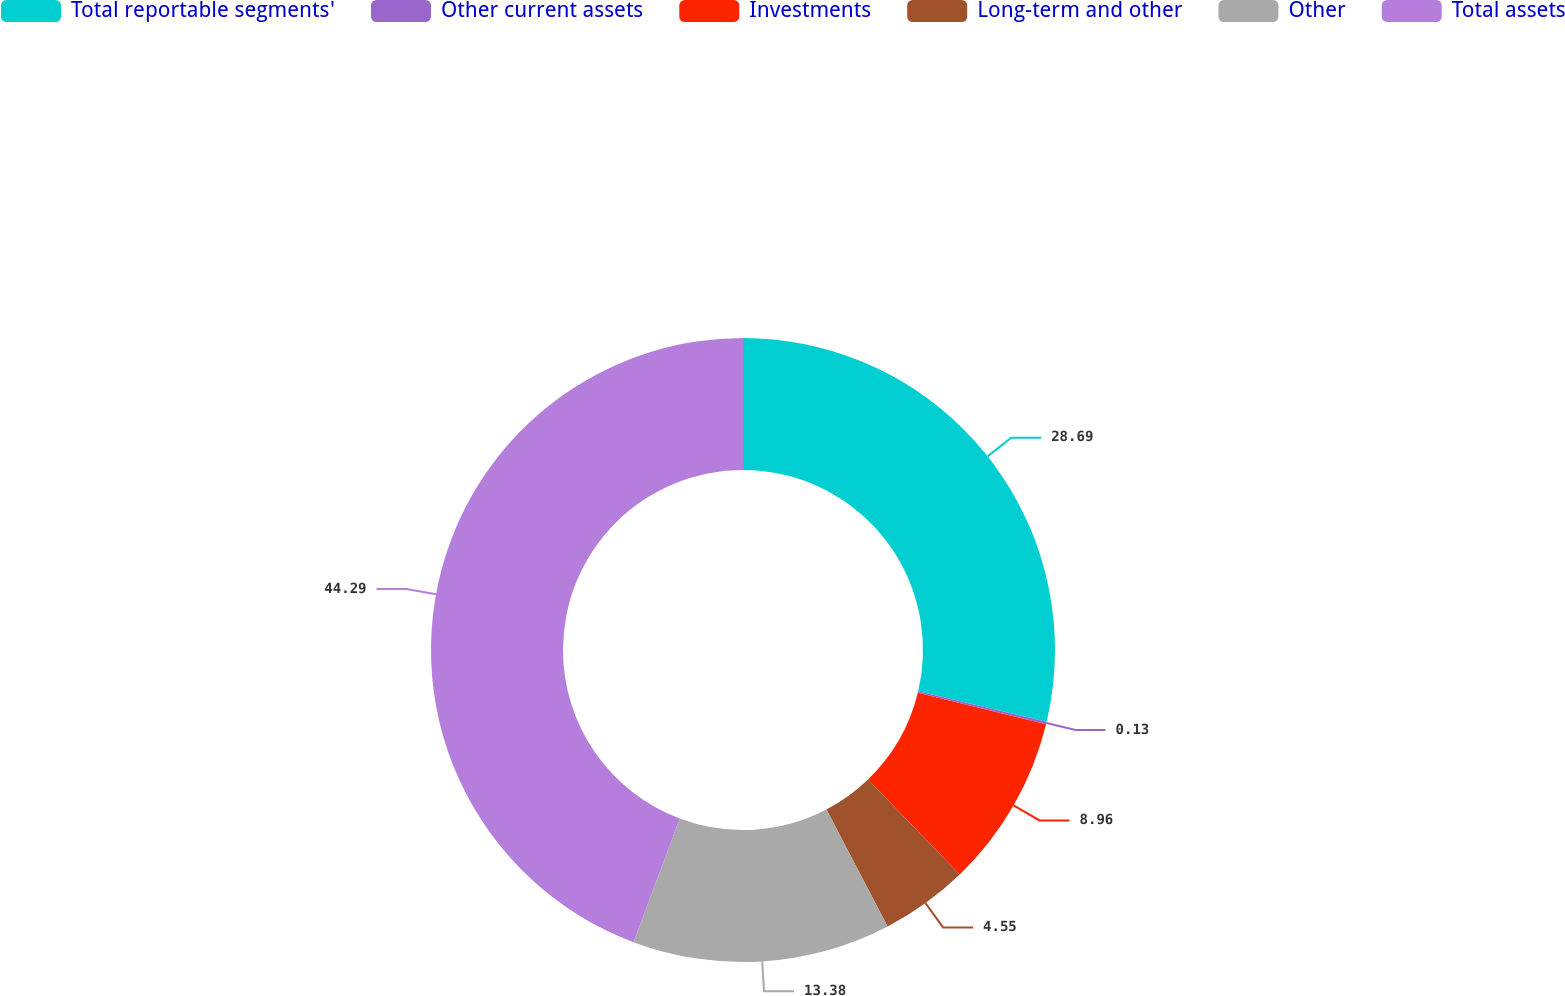<chart> <loc_0><loc_0><loc_500><loc_500><pie_chart><fcel>Total reportable segments'<fcel>Other current assets<fcel>Investments<fcel>Long-term and other<fcel>Other<fcel>Total assets<nl><fcel>28.69%<fcel>0.13%<fcel>8.96%<fcel>4.55%<fcel>13.38%<fcel>44.29%<nl></chart> 